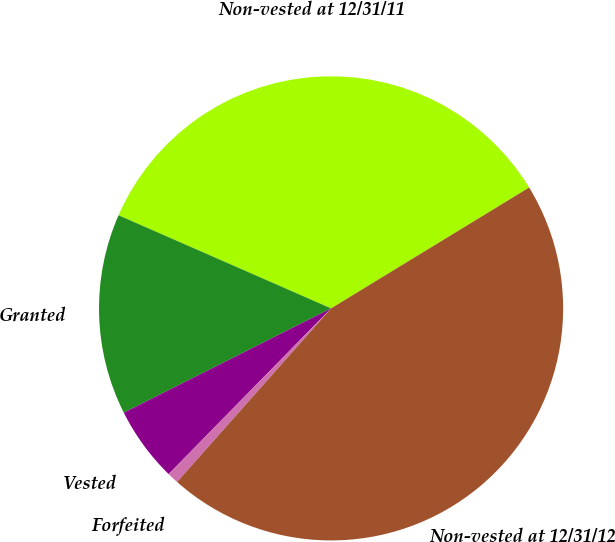Convert chart to OTSL. <chart><loc_0><loc_0><loc_500><loc_500><pie_chart><fcel>Non-vested at 12/31/11<fcel>Granted<fcel>Vested<fcel>Forfeited<fcel>Non-vested at 12/31/12<nl><fcel>34.71%<fcel>13.99%<fcel>5.24%<fcel>0.79%<fcel>45.27%<nl></chart> 